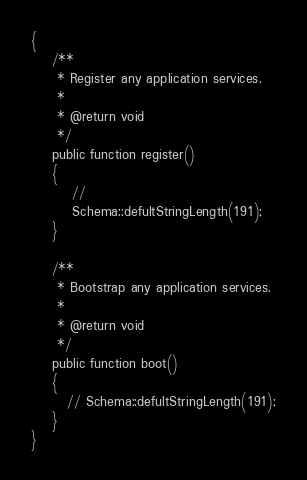<code> <loc_0><loc_0><loc_500><loc_500><_PHP_>{
    /**
     * Register any application services.
     *
     * @return void
     */
    public function register()
    {
        //
        Schema::defultStringLength(191);
    }

    /**
     * Bootstrap any application services.
     *
     * @return void
     */
    public function boot()
    {
       // Schema::defultStringLength(191);
    }
}
</code> 